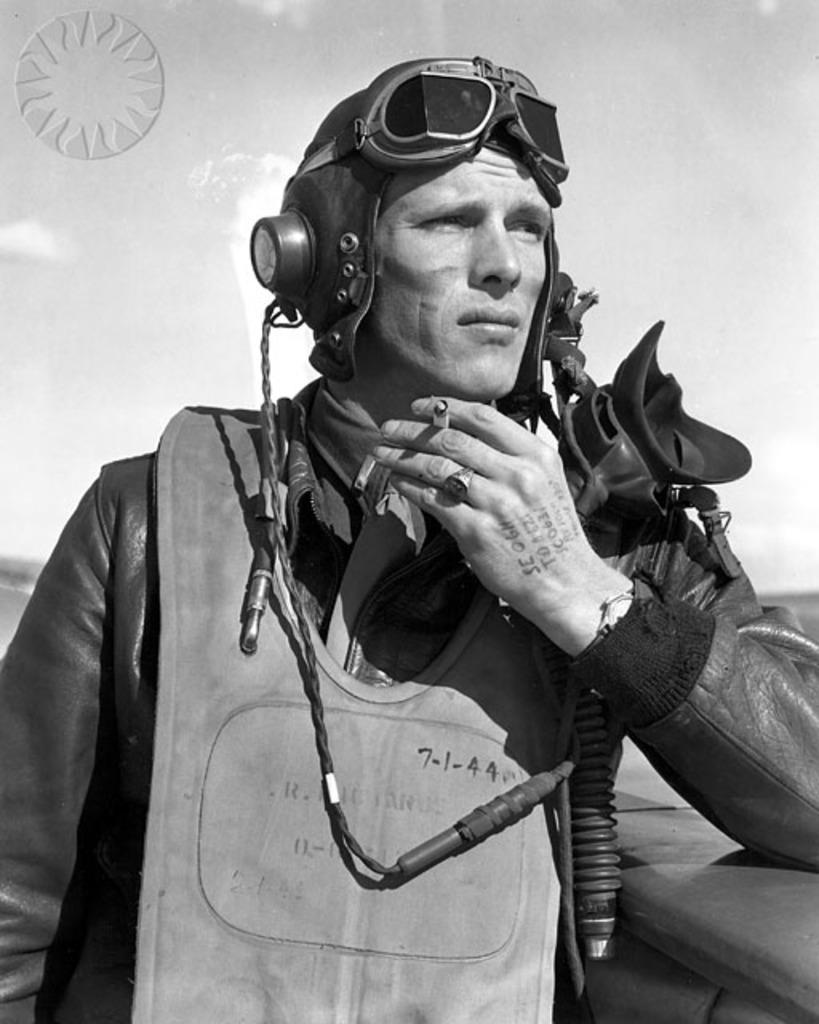Describe this image in one or two sentences. In this image in the front there is a man standing and leaning on the wall and the background is blurry. 